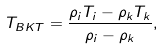<formula> <loc_0><loc_0><loc_500><loc_500>T _ { B K T } = \frac { \rho _ { i } T _ { i } - \rho _ { k } T _ { k } } { \rho _ { i } - \rho _ { k } } ,</formula> 